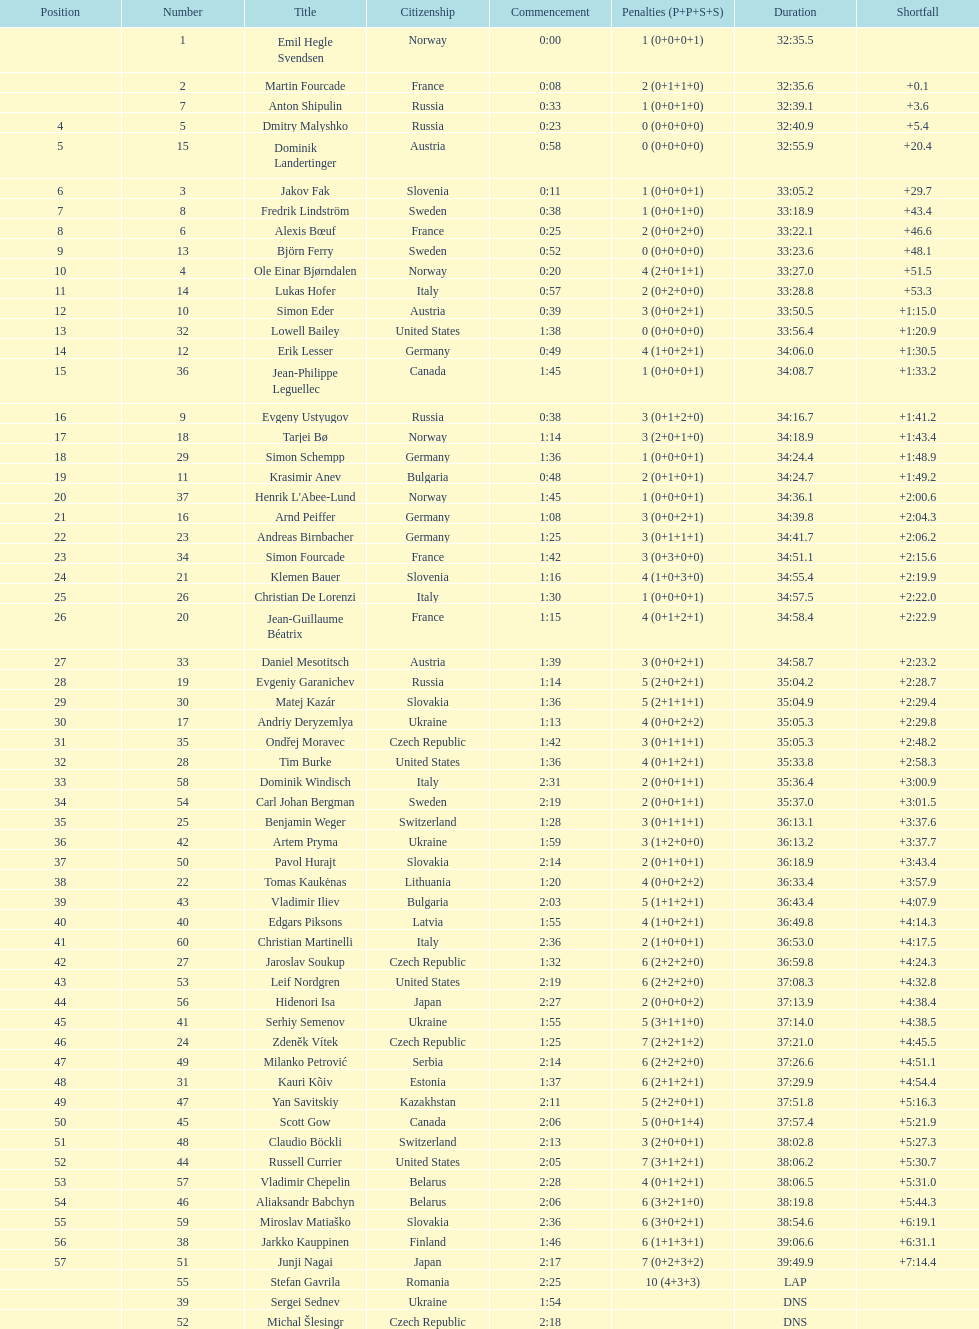Other than burke, name an athlete from the us. Leif Nordgren. 